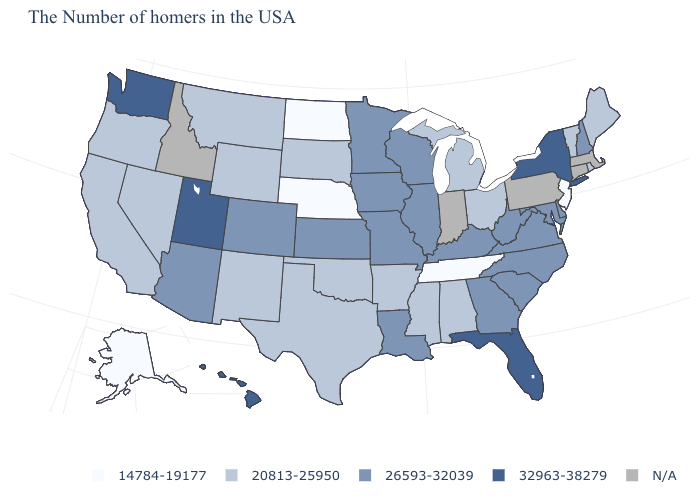Name the states that have a value in the range 14784-19177?
Keep it brief. New Jersey, Tennessee, Nebraska, North Dakota, Alaska. Name the states that have a value in the range 26593-32039?
Quick response, please. New Hampshire, Delaware, Maryland, Virginia, North Carolina, South Carolina, West Virginia, Georgia, Kentucky, Wisconsin, Illinois, Louisiana, Missouri, Minnesota, Iowa, Kansas, Colorado, Arizona. Is the legend a continuous bar?
Concise answer only. No. Name the states that have a value in the range 20813-25950?
Give a very brief answer. Maine, Rhode Island, Vermont, Ohio, Michigan, Alabama, Mississippi, Arkansas, Oklahoma, Texas, South Dakota, Wyoming, New Mexico, Montana, Nevada, California, Oregon. Name the states that have a value in the range 20813-25950?
Quick response, please. Maine, Rhode Island, Vermont, Ohio, Michigan, Alabama, Mississippi, Arkansas, Oklahoma, Texas, South Dakota, Wyoming, New Mexico, Montana, Nevada, California, Oregon. Name the states that have a value in the range N/A?
Give a very brief answer. Massachusetts, Connecticut, Pennsylvania, Indiana, Idaho. What is the value of South Carolina?
Answer briefly. 26593-32039. Which states hav the highest value in the South?
Write a very short answer. Florida. Name the states that have a value in the range 32963-38279?
Concise answer only. New York, Florida, Utah, Washington, Hawaii. Among the states that border Arizona , which have the highest value?
Be succinct. Utah. What is the highest value in the USA?
Give a very brief answer. 32963-38279. Among the states that border Nebraska , which have the lowest value?
Answer briefly. South Dakota, Wyoming. What is the highest value in the MidWest ?
Answer briefly. 26593-32039. Does California have the highest value in the USA?
Keep it brief. No. 